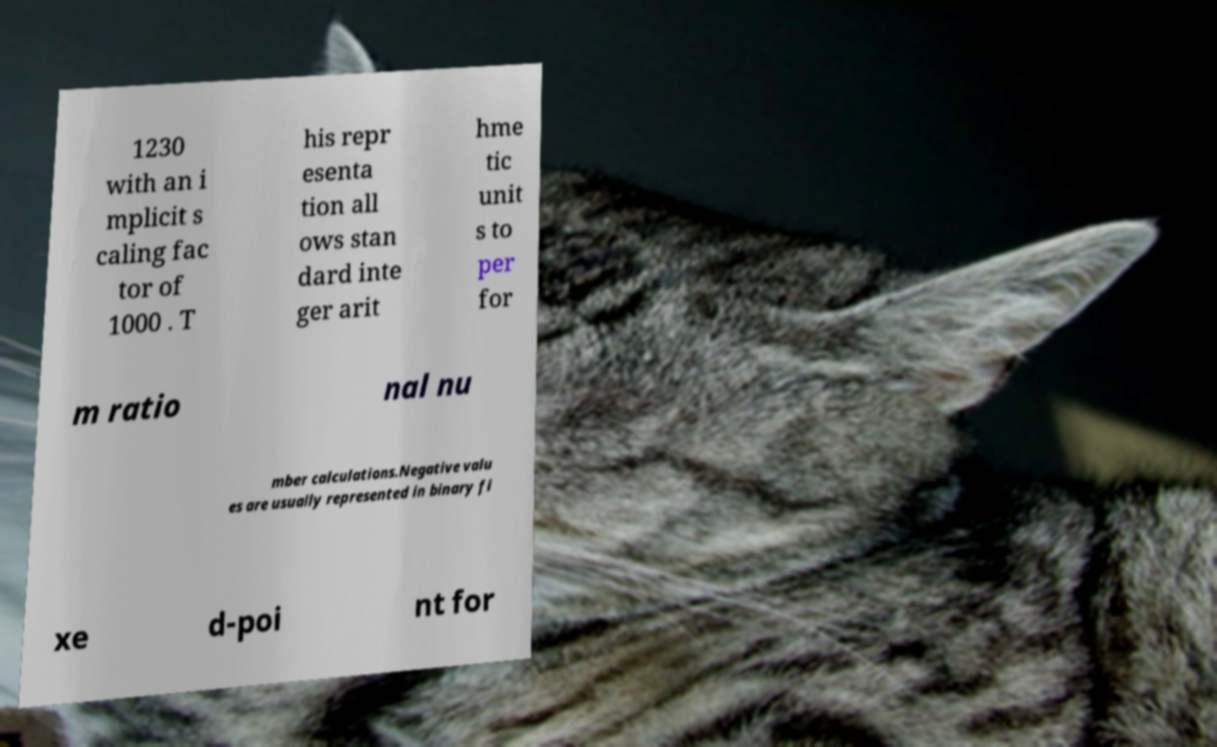I need the written content from this picture converted into text. Can you do that? 1230 with an i mplicit s caling fac tor of 1000 . T his repr esenta tion all ows stan dard inte ger arit hme tic unit s to per for m ratio nal nu mber calculations.Negative valu es are usually represented in binary fi xe d-poi nt for 